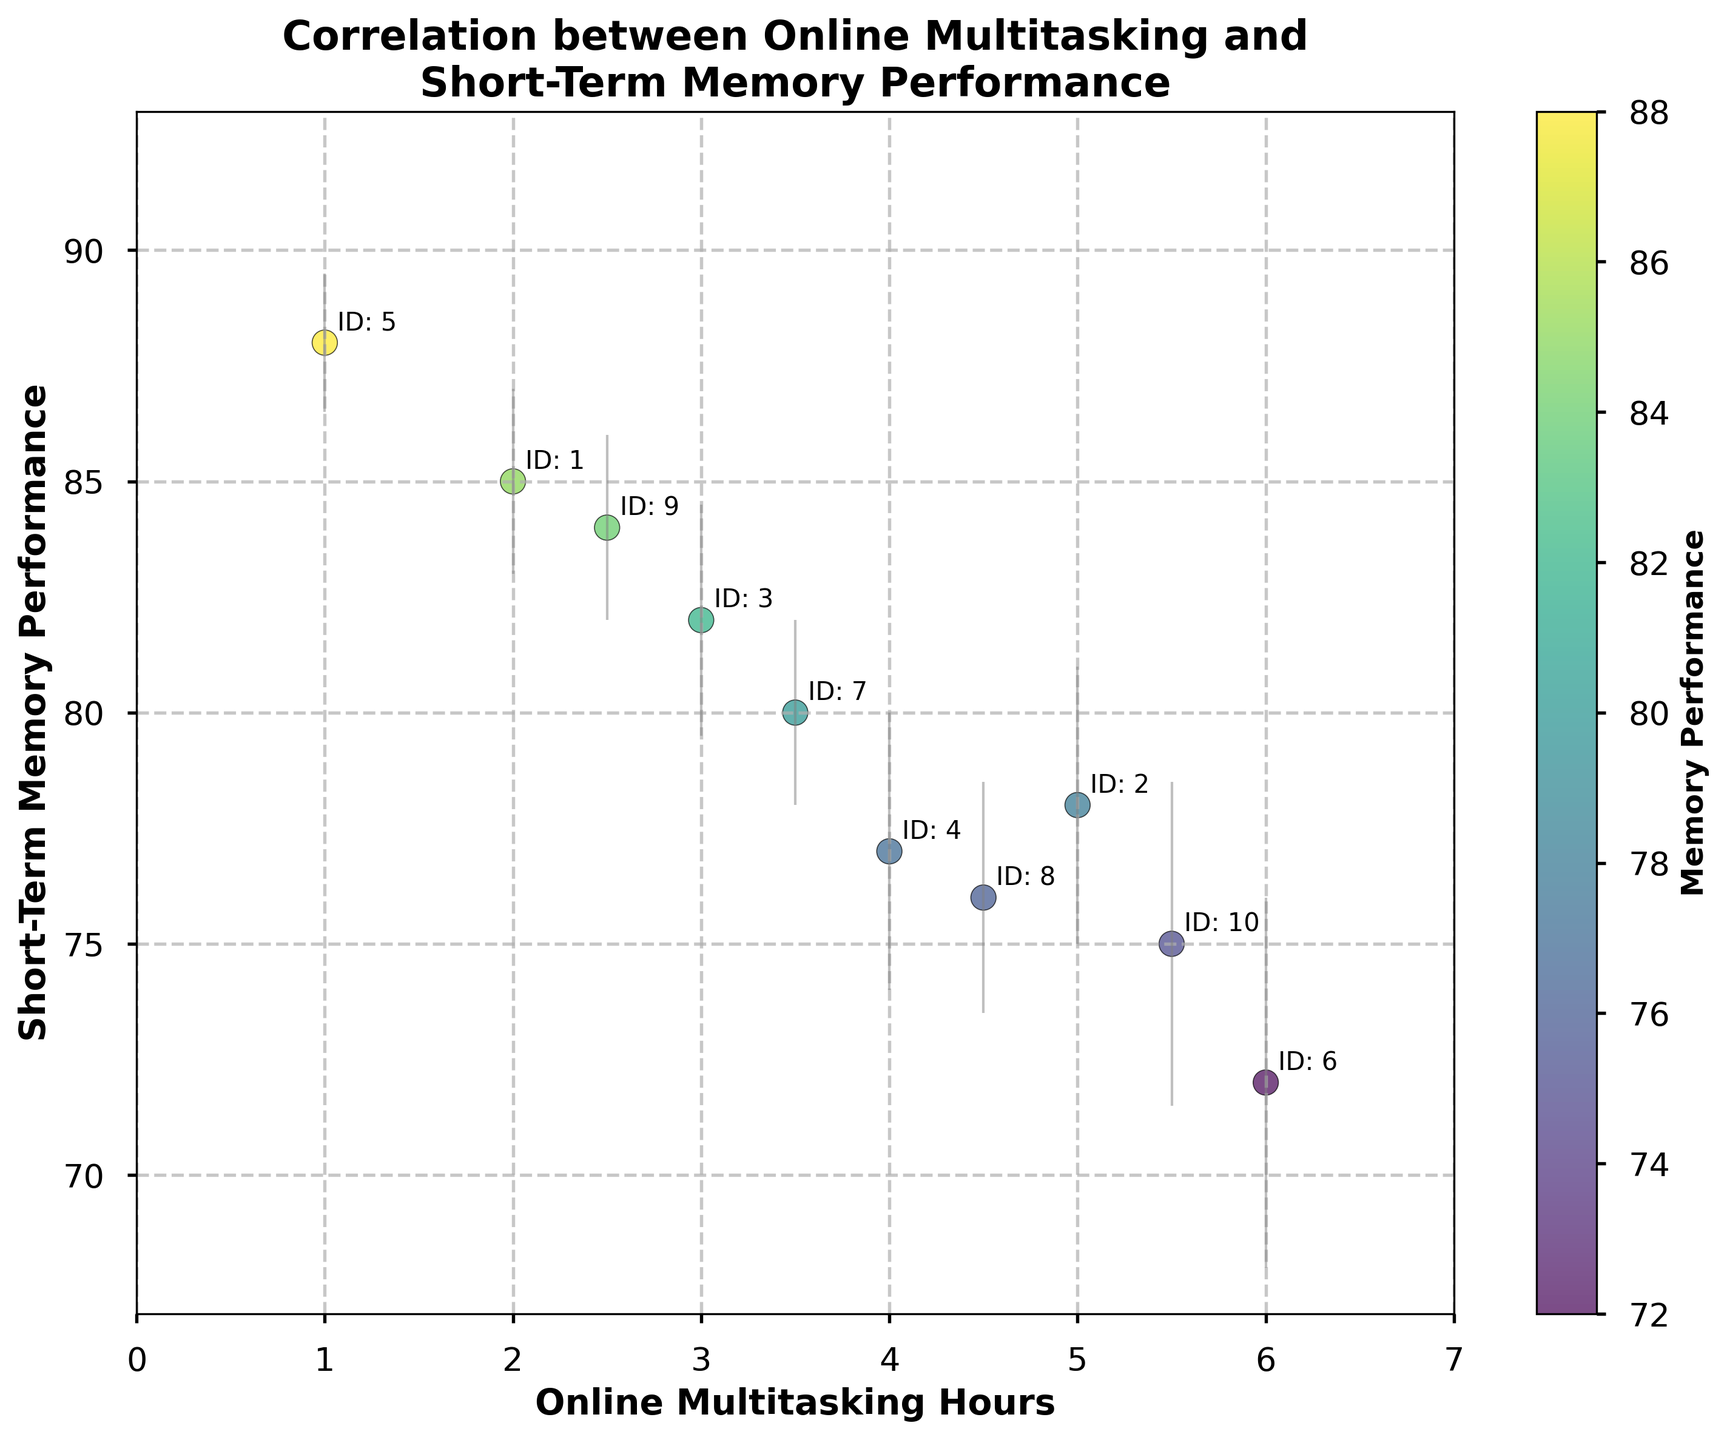What is the title of the plot? The title is typically located at the top of the plot and describes the content or relationship being visualized.
Answer: Correlation between Online Multitasking and Short-Term Memory Performance How many data points are included in the scatter plot? The data points are represented by markers on the scatter plot. To determine the number of data points, one can simply count all such markers.
Answer: 10 Which student has the highest short-term memory performance, and what is their online multitasking hours? By looking at the scatter plot, identify the data point with the highest y-value and note the corresponding x-value and the student ID annotated next to it.
Answer: Student 5, 1 hour What is the general trend between online multitasking hours and short-term memory performance? Examine the distribution of data points to determine whether there is an upward or downward trend as online multitasking hours increase. This is often reflected by an overall direction in the scatter plot.
Answer: Negative correlation Which student has the greatest error margin, and what is it? Identify the error bars on the data points, and find the one with the largest vertical extent. The student ID is annotated next to the respective data point.
Answer: Student 6, 4 Compare the short-term memory performance of students with exactly 3 and 4 hours of multitasking. Which is higher? Locate the data points where Online Multitasking Hours are 3 and 4, then compare their y-values to determine which one is higher.
Answer: 3 hours What is the average short-term memory performance for students who multitask for more than 4 hours? Identify data points with Online Multitasking Hours greater than 4, sum their Short-Term Memory Performance values, and divide by the number of such students.
Answer: 75.25 What is the x-axis label and what does it represent? The x-axis label is found along the horizontal axis of the plot, describing what is measured by this axis.
Answer: Online Multitasking Hours Do any students have the same short-term memory performance? Look for data points that have the same y-value on the scatter plot to determine if any students share the same performance.
Answer: No 